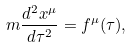<formula> <loc_0><loc_0><loc_500><loc_500>m \frac { d ^ { 2 } x ^ { \mu } } { d \tau ^ { 2 } } = f ^ { \mu } ( \tau ) ,</formula> 